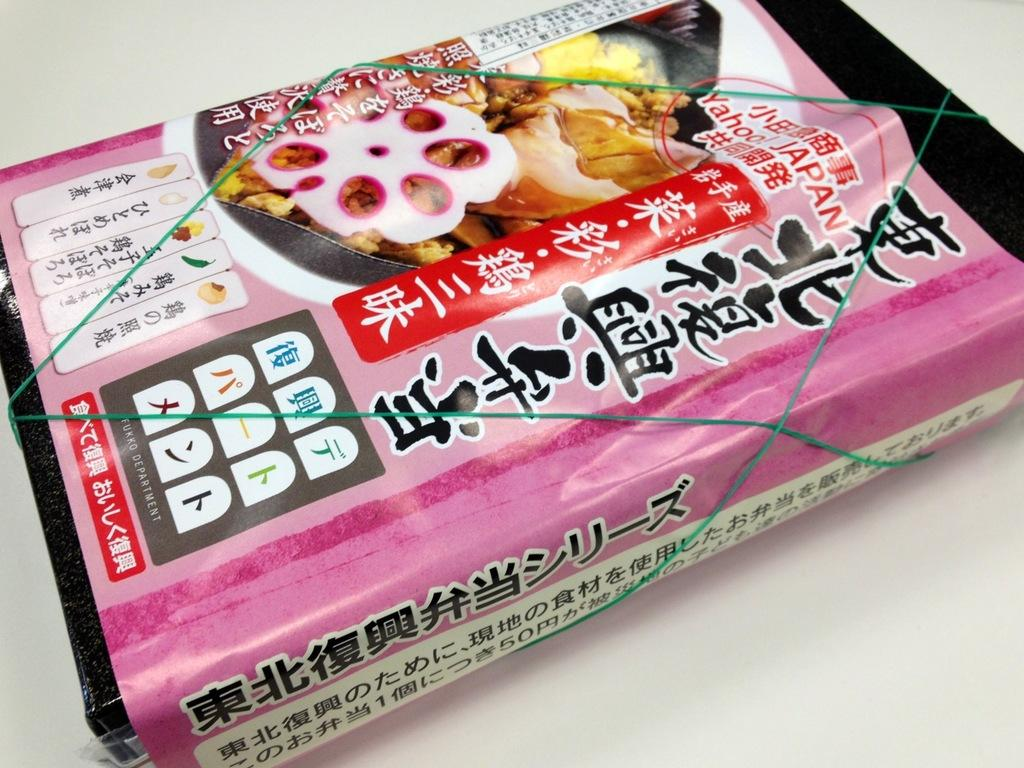What can be seen in the image? There is an object in the image. How is the object in the image covered or protected? The object is wrapped with paper. How is the paper secured around the object? The paper is tied with a rubber band. Are there any dinosaurs visible in the image? No, there are no dinosaurs present in the image. Can you see a mountain in the background of the image? No, there is no mountain visible in the image. 